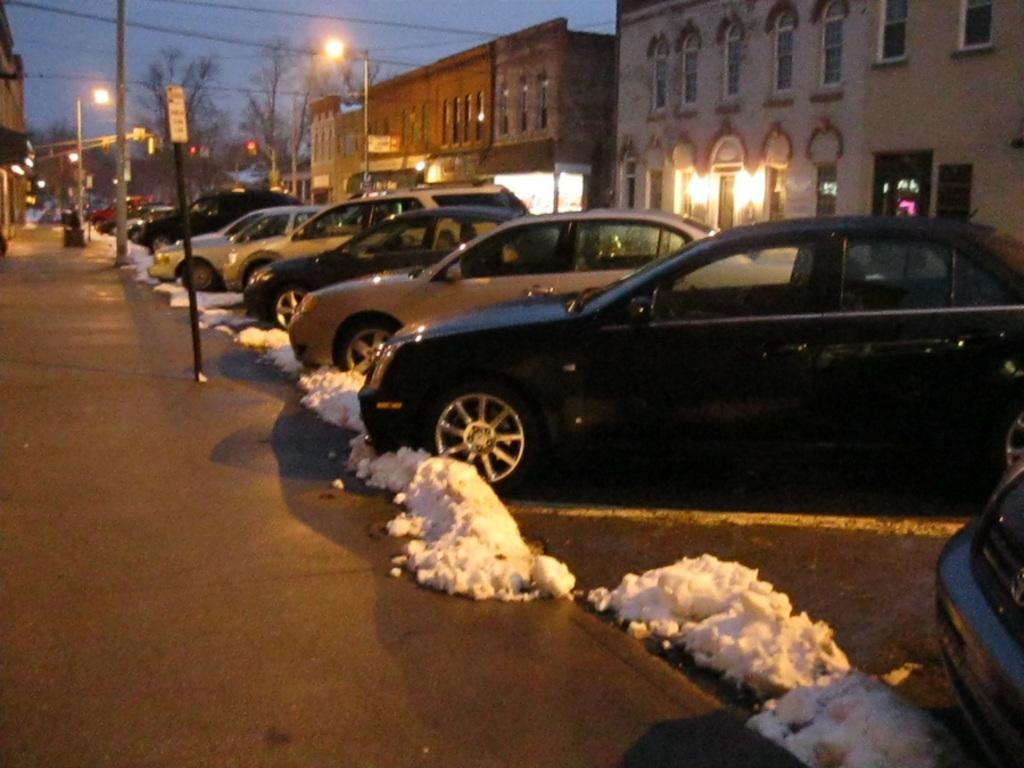In one or two sentences, can you explain what this image depicts? In this image we can see cars placed in a row. There are poles and we can see buildings. At the bottom there is snow and a road. In the background there are trees, lights, wires and sky. 